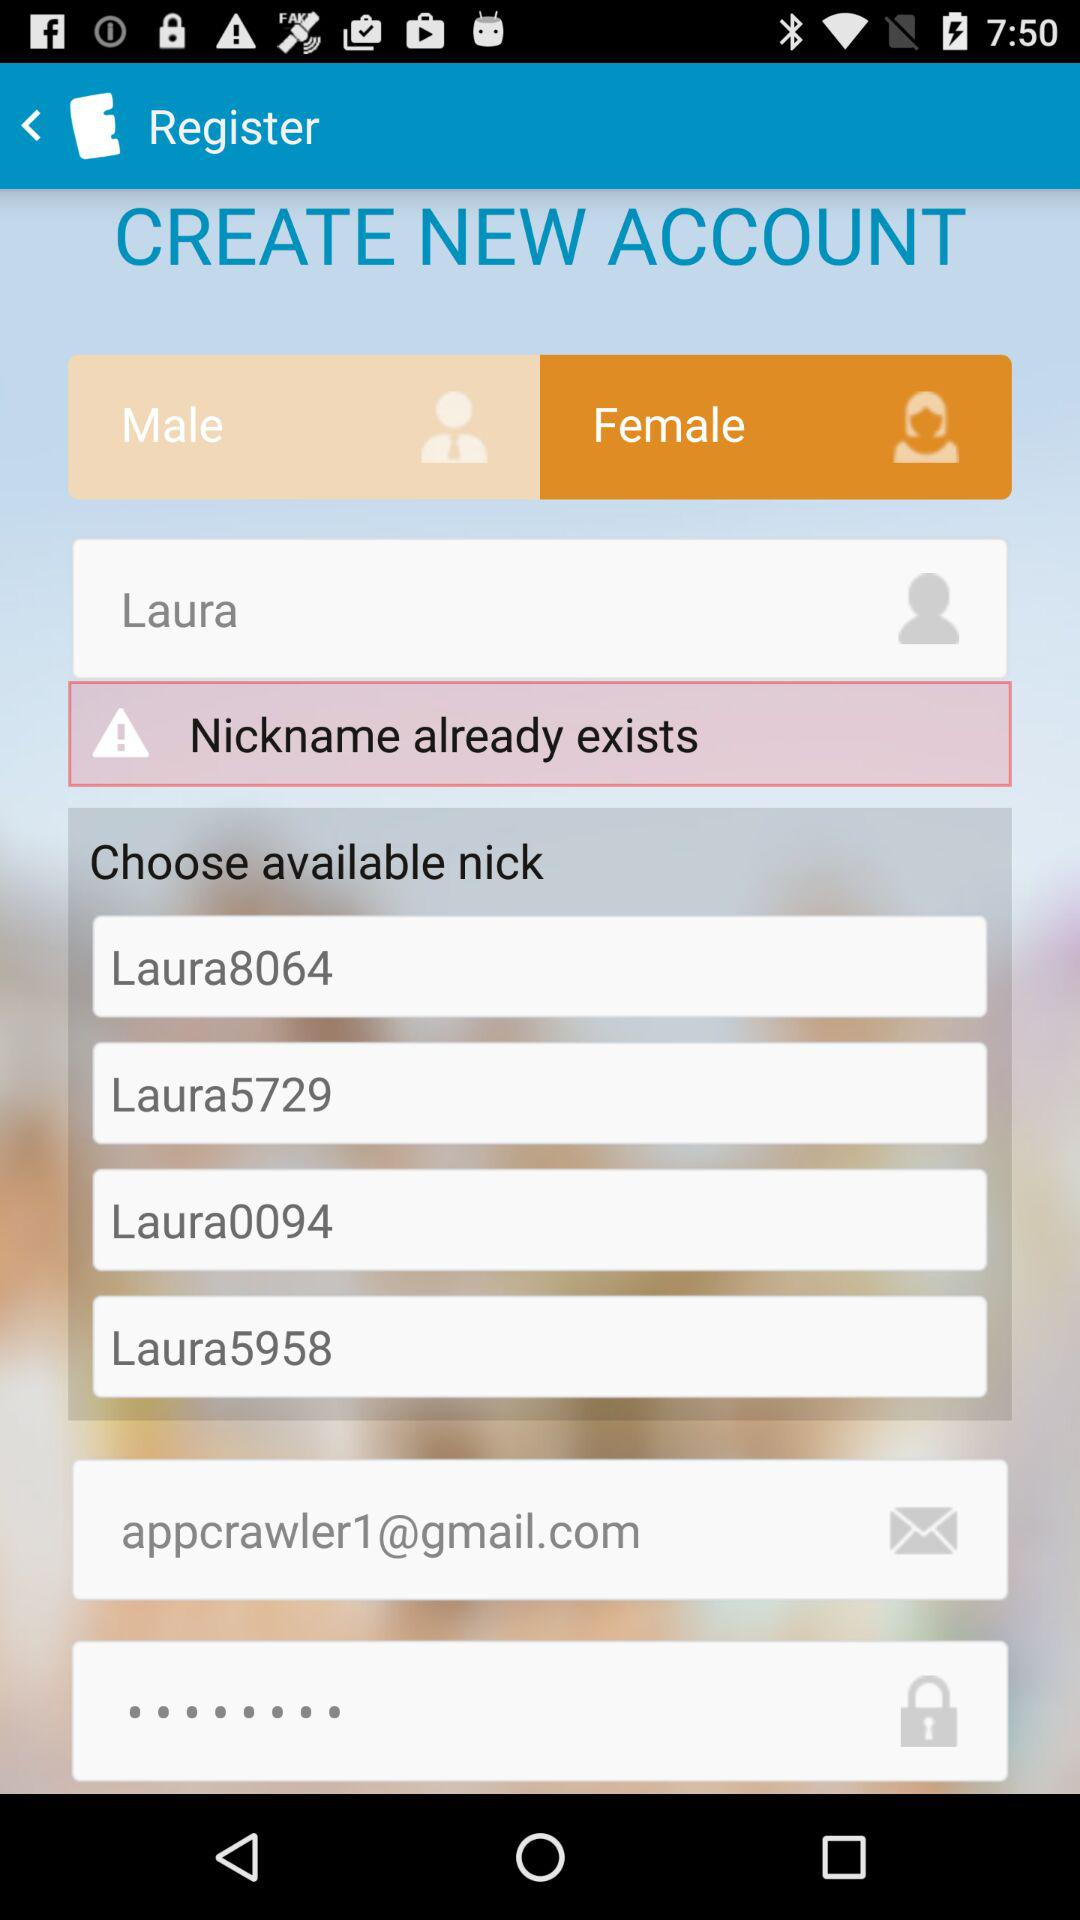What is the email address? The email address is appcrawler1@gmail.com. 